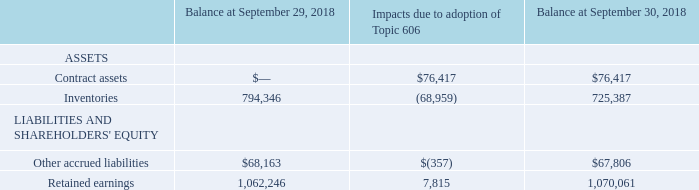15. Revenue from Contracts with Customers
Impact of Adopting Topic 606
The Company adopted Topic 606 at the beginning of fiscal 2019 using the modified retrospective method. The new standard resulted in a change to the timing of revenue recognition for a significant portion of the Company's revenue, whereby revenue is recognized over time, as products are produced, as opposed to at a point in time based upon shipping terms. As a result of the adoption of Topic 606, the following adjustments were made to the opening balances of the Company's Consolidated Balance Sheets (in thousands):
The cumulative effect of applying the new guidance in Topic 606 resulted in the Company increasing its fiscal 2019 opening Retained earnings balance by$ 7.8 million due to certain customer contracts requiring revenue recognition over time. Contract assets in the amount of$ 76.4 million were recognized due to the recognition of revenue on an over time basis for some customers rather than at a specific point in time. Inventory declined $69.0 million primarily due to earlier recognition of costs related to the contracts for which revenue was recognized on an over time basis. The decline in other accrued liabilities is primarily due to the reclassification of deferred revenue to contract assets for prepayments associated with revenue recognized over time, partially offset by an increase in taxes payable associated with the increase in revenue recognized over time.
How did the company adopt Topic 606 at the beginning of Fiscal 2019? Using the modified retrospective method. What was the balance of contract assets after the adoption of Topic 606?
Answer scale should be: thousand. 76,417. What was the balance of Inventories before adoption of Topic 606?
Answer scale should be: thousand. 794,346. How many assets and liabilities had an end balance at September 30, 2019 that exceeded $1,000,000 thousand? Retained earnings
Answer: 1. What was the difference between the impacts due to adoption of Topic 606 between Contract assets and inventories?
Answer scale should be: thousand. 76,417-(-68,959)
Answer: 145376. What was the percentage change in other accrued liabilities between before and after the impact of Topic 606?
Answer scale should be: percent. (67,806-68,163)/68,163
Answer: -0.52. 